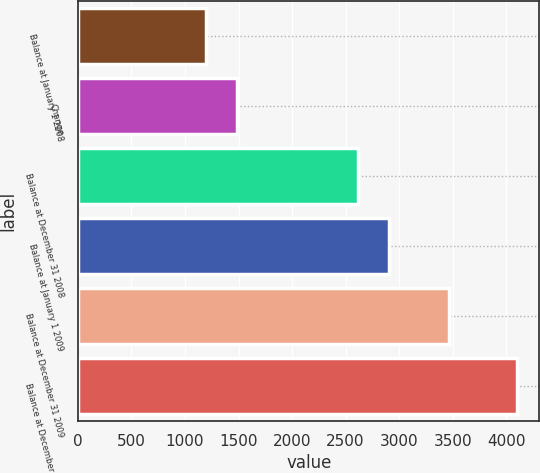Convert chart to OTSL. <chart><loc_0><loc_0><loc_500><loc_500><bar_chart><fcel>Balance at January 1 2008<fcel>Change<fcel>Balance at December 31 2008<fcel>Balance at January 1 2009<fcel>Balance at December 31 2009<fcel>Balance at December 31 2010<nl><fcel>1196<fcel>1486.9<fcel>2615<fcel>2905.9<fcel>3461<fcel>4105<nl></chart> 